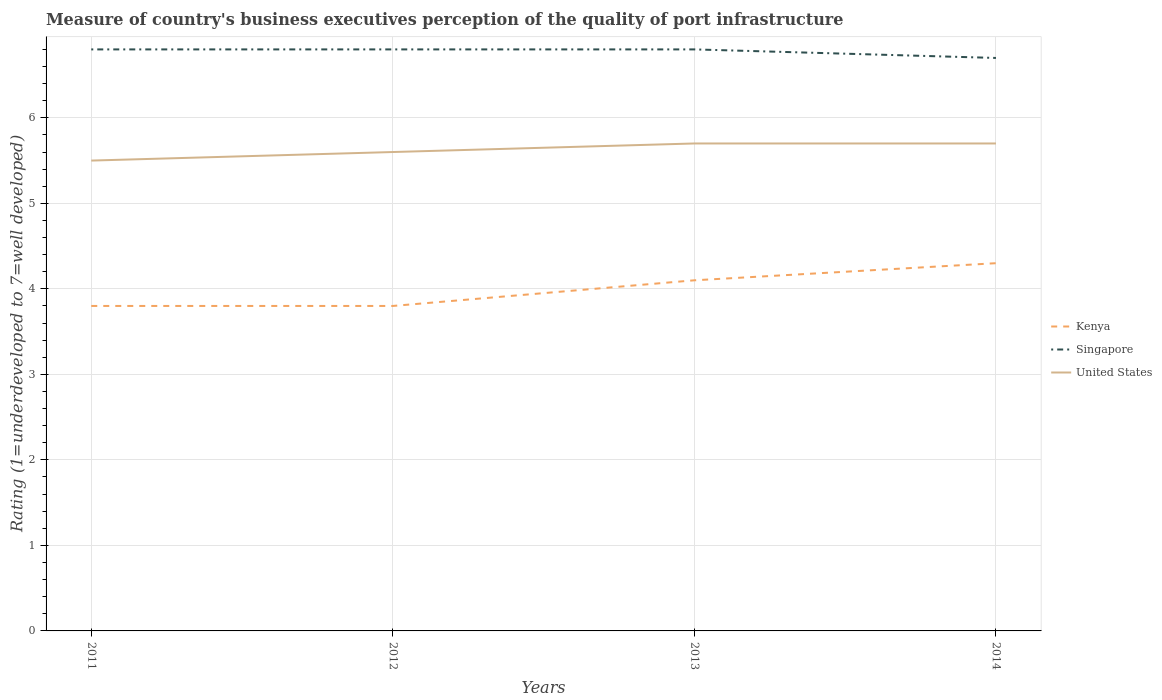How many different coloured lines are there?
Your answer should be compact. 3. Does the line corresponding to United States intersect with the line corresponding to Kenya?
Your answer should be compact. No. What is the difference between the highest and the second highest ratings of the quality of port infrastructure in Singapore?
Provide a short and direct response. 0.1. What is the difference between the highest and the lowest ratings of the quality of port infrastructure in United States?
Your answer should be very brief. 2. How many lines are there?
Offer a very short reply. 3. What is the difference between two consecutive major ticks on the Y-axis?
Your response must be concise. 1. Does the graph contain any zero values?
Offer a terse response. No. Does the graph contain grids?
Your answer should be very brief. Yes. How are the legend labels stacked?
Provide a short and direct response. Vertical. What is the title of the graph?
Make the answer very short. Measure of country's business executives perception of the quality of port infrastructure. Does "Maldives" appear as one of the legend labels in the graph?
Ensure brevity in your answer.  No. What is the label or title of the X-axis?
Provide a succinct answer. Years. What is the label or title of the Y-axis?
Your answer should be very brief. Rating (1=underdeveloped to 7=well developed). What is the Rating (1=underdeveloped to 7=well developed) of Singapore in 2011?
Provide a short and direct response. 6.8. What is the Rating (1=underdeveloped to 7=well developed) of United States in 2011?
Give a very brief answer. 5.5. What is the Rating (1=underdeveloped to 7=well developed) in United States in 2012?
Make the answer very short. 5.6. What is the Rating (1=underdeveloped to 7=well developed) in Singapore in 2013?
Ensure brevity in your answer.  6.8. What is the Rating (1=underdeveloped to 7=well developed) of Kenya in 2014?
Ensure brevity in your answer.  4.3. What is the Rating (1=underdeveloped to 7=well developed) in Singapore in 2014?
Provide a short and direct response. 6.7. What is the Rating (1=underdeveloped to 7=well developed) in United States in 2014?
Offer a terse response. 5.7. Across all years, what is the maximum Rating (1=underdeveloped to 7=well developed) of Kenya?
Your answer should be very brief. 4.3. Across all years, what is the maximum Rating (1=underdeveloped to 7=well developed) in United States?
Your answer should be very brief. 5.7. Across all years, what is the minimum Rating (1=underdeveloped to 7=well developed) of United States?
Your answer should be compact. 5.5. What is the total Rating (1=underdeveloped to 7=well developed) in Singapore in the graph?
Make the answer very short. 27.1. What is the total Rating (1=underdeveloped to 7=well developed) in United States in the graph?
Your response must be concise. 22.5. What is the difference between the Rating (1=underdeveloped to 7=well developed) in Kenya in 2011 and that in 2012?
Your answer should be very brief. 0. What is the difference between the Rating (1=underdeveloped to 7=well developed) of Singapore in 2011 and that in 2012?
Your response must be concise. 0. What is the difference between the Rating (1=underdeveloped to 7=well developed) in United States in 2011 and that in 2012?
Provide a short and direct response. -0.1. What is the difference between the Rating (1=underdeveloped to 7=well developed) of Kenya in 2011 and that in 2013?
Your answer should be compact. -0.3. What is the difference between the Rating (1=underdeveloped to 7=well developed) of United States in 2011 and that in 2013?
Keep it short and to the point. -0.2. What is the difference between the Rating (1=underdeveloped to 7=well developed) in Kenya in 2011 and that in 2014?
Make the answer very short. -0.5. What is the difference between the Rating (1=underdeveloped to 7=well developed) of Singapore in 2011 and that in 2014?
Offer a very short reply. 0.1. What is the difference between the Rating (1=underdeveloped to 7=well developed) in Singapore in 2012 and that in 2013?
Provide a succinct answer. 0. What is the difference between the Rating (1=underdeveloped to 7=well developed) of United States in 2012 and that in 2013?
Ensure brevity in your answer.  -0.1. What is the difference between the Rating (1=underdeveloped to 7=well developed) in Kenya in 2012 and that in 2014?
Provide a short and direct response. -0.5. What is the difference between the Rating (1=underdeveloped to 7=well developed) of Singapore in 2012 and that in 2014?
Provide a succinct answer. 0.1. What is the difference between the Rating (1=underdeveloped to 7=well developed) in Kenya in 2013 and that in 2014?
Provide a succinct answer. -0.2. What is the difference between the Rating (1=underdeveloped to 7=well developed) of United States in 2013 and that in 2014?
Ensure brevity in your answer.  0. What is the difference between the Rating (1=underdeveloped to 7=well developed) in Kenya in 2011 and the Rating (1=underdeveloped to 7=well developed) in United States in 2012?
Offer a terse response. -1.8. What is the difference between the Rating (1=underdeveloped to 7=well developed) in Kenya in 2011 and the Rating (1=underdeveloped to 7=well developed) in Singapore in 2013?
Ensure brevity in your answer.  -3. What is the difference between the Rating (1=underdeveloped to 7=well developed) in Kenya in 2011 and the Rating (1=underdeveloped to 7=well developed) in United States in 2013?
Provide a succinct answer. -1.9. What is the difference between the Rating (1=underdeveloped to 7=well developed) in Kenya in 2011 and the Rating (1=underdeveloped to 7=well developed) in Singapore in 2014?
Provide a short and direct response. -2.9. What is the difference between the Rating (1=underdeveloped to 7=well developed) in Kenya in 2012 and the Rating (1=underdeveloped to 7=well developed) in Singapore in 2013?
Keep it short and to the point. -3. What is the difference between the Rating (1=underdeveloped to 7=well developed) of Kenya in 2012 and the Rating (1=underdeveloped to 7=well developed) of United States in 2013?
Keep it short and to the point. -1.9. What is the difference between the Rating (1=underdeveloped to 7=well developed) in Kenya in 2012 and the Rating (1=underdeveloped to 7=well developed) in Singapore in 2014?
Your answer should be very brief. -2.9. What is the difference between the Rating (1=underdeveloped to 7=well developed) in Singapore in 2013 and the Rating (1=underdeveloped to 7=well developed) in United States in 2014?
Provide a short and direct response. 1.1. What is the average Rating (1=underdeveloped to 7=well developed) in Singapore per year?
Make the answer very short. 6.78. What is the average Rating (1=underdeveloped to 7=well developed) in United States per year?
Keep it short and to the point. 5.62. In the year 2011, what is the difference between the Rating (1=underdeveloped to 7=well developed) of Kenya and Rating (1=underdeveloped to 7=well developed) of Singapore?
Ensure brevity in your answer.  -3. In the year 2011, what is the difference between the Rating (1=underdeveloped to 7=well developed) in Kenya and Rating (1=underdeveloped to 7=well developed) in United States?
Provide a short and direct response. -1.7. In the year 2012, what is the difference between the Rating (1=underdeveloped to 7=well developed) in Singapore and Rating (1=underdeveloped to 7=well developed) in United States?
Give a very brief answer. 1.2. In the year 2013, what is the difference between the Rating (1=underdeveloped to 7=well developed) in Kenya and Rating (1=underdeveloped to 7=well developed) in United States?
Offer a terse response. -1.6. In the year 2014, what is the difference between the Rating (1=underdeveloped to 7=well developed) in Kenya and Rating (1=underdeveloped to 7=well developed) in Singapore?
Offer a terse response. -2.4. In the year 2014, what is the difference between the Rating (1=underdeveloped to 7=well developed) in Kenya and Rating (1=underdeveloped to 7=well developed) in United States?
Keep it short and to the point. -1.4. In the year 2014, what is the difference between the Rating (1=underdeveloped to 7=well developed) in Singapore and Rating (1=underdeveloped to 7=well developed) in United States?
Keep it short and to the point. 1. What is the ratio of the Rating (1=underdeveloped to 7=well developed) of United States in 2011 to that in 2012?
Your response must be concise. 0.98. What is the ratio of the Rating (1=underdeveloped to 7=well developed) in Kenya in 2011 to that in 2013?
Ensure brevity in your answer.  0.93. What is the ratio of the Rating (1=underdeveloped to 7=well developed) in Singapore in 2011 to that in 2013?
Offer a very short reply. 1. What is the ratio of the Rating (1=underdeveloped to 7=well developed) in United States in 2011 to that in 2013?
Offer a very short reply. 0.96. What is the ratio of the Rating (1=underdeveloped to 7=well developed) in Kenya in 2011 to that in 2014?
Your answer should be compact. 0.88. What is the ratio of the Rating (1=underdeveloped to 7=well developed) in Singapore in 2011 to that in 2014?
Give a very brief answer. 1.01. What is the ratio of the Rating (1=underdeveloped to 7=well developed) of United States in 2011 to that in 2014?
Ensure brevity in your answer.  0.96. What is the ratio of the Rating (1=underdeveloped to 7=well developed) of Kenya in 2012 to that in 2013?
Keep it short and to the point. 0.93. What is the ratio of the Rating (1=underdeveloped to 7=well developed) in Singapore in 2012 to that in 2013?
Offer a very short reply. 1. What is the ratio of the Rating (1=underdeveloped to 7=well developed) of United States in 2012 to that in 2013?
Ensure brevity in your answer.  0.98. What is the ratio of the Rating (1=underdeveloped to 7=well developed) in Kenya in 2012 to that in 2014?
Make the answer very short. 0.88. What is the ratio of the Rating (1=underdeveloped to 7=well developed) of Singapore in 2012 to that in 2014?
Provide a succinct answer. 1.01. What is the ratio of the Rating (1=underdeveloped to 7=well developed) of United States in 2012 to that in 2014?
Provide a short and direct response. 0.98. What is the ratio of the Rating (1=underdeveloped to 7=well developed) of Kenya in 2013 to that in 2014?
Ensure brevity in your answer.  0.95. What is the ratio of the Rating (1=underdeveloped to 7=well developed) in Singapore in 2013 to that in 2014?
Ensure brevity in your answer.  1.01. What is the difference between the highest and the second highest Rating (1=underdeveloped to 7=well developed) in Singapore?
Provide a succinct answer. 0. What is the difference between the highest and the lowest Rating (1=underdeveloped to 7=well developed) in United States?
Provide a succinct answer. 0.2. 